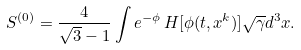<formula> <loc_0><loc_0><loc_500><loc_500>S ^ { ( 0 ) } = \frac { 4 } { \sqrt { 3 } - 1 } \int e ^ { - \phi } \, H [ \phi ( t , x ^ { k } ) ] \sqrt { \gamma } d ^ { 3 } x .</formula> 